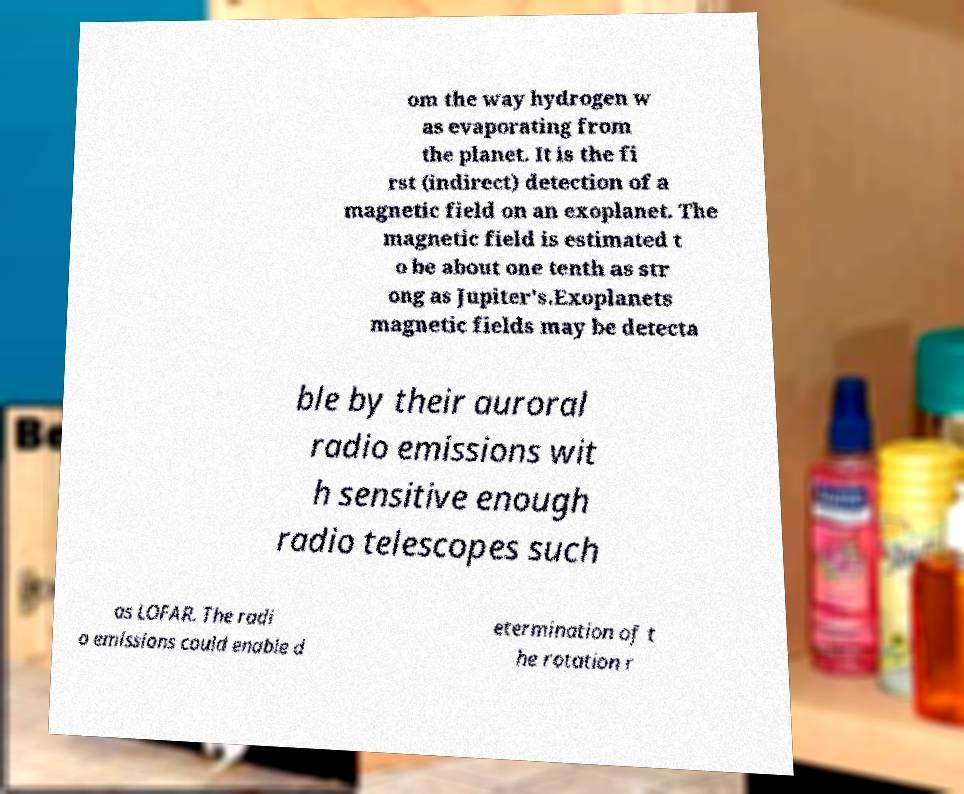I need the written content from this picture converted into text. Can you do that? om the way hydrogen w as evaporating from the planet. It is the fi rst (indirect) detection of a magnetic field on an exoplanet. The magnetic field is estimated t o be about one tenth as str ong as Jupiter's.Exoplanets magnetic fields may be detecta ble by their auroral radio emissions wit h sensitive enough radio telescopes such as LOFAR. The radi o emissions could enable d etermination of t he rotation r 